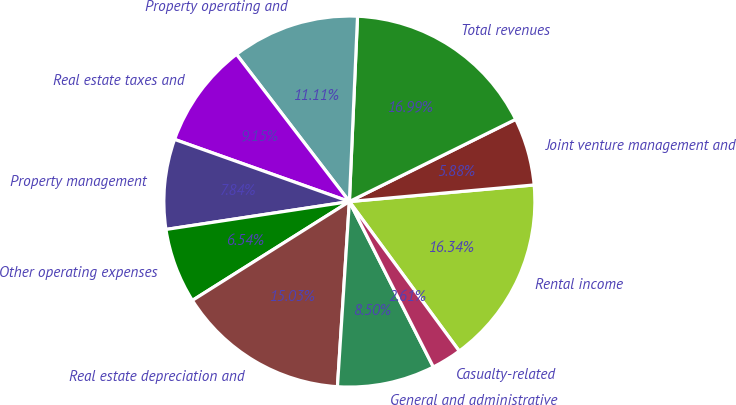Convert chart to OTSL. <chart><loc_0><loc_0><loc_500><loc_500><pie_chart><fcel>Rental income<fcel>Joint venture management and<fcel>Total revenues<fcel>Property operating and<fcel>Real estate taxes and<fcel>Property management<fcel>Other operating expenses<fcel>Real estate depreciation and<fcel>General and administrative<fcel>Casualty-related<nl><fcel>16.34%<fcel>5.88%<fcel>16.99%<fcel>11.11%<fcel>9.15%<fcel>7.84%<fcel>6.54%<fcel>15.03%<fcel>8.5%<fcel>2.61%<nl></chart> 